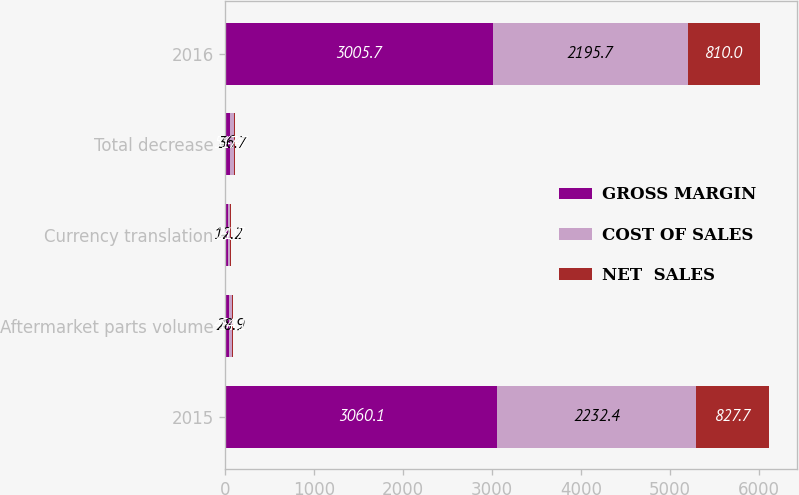<chart> <loc_0><loc_0><loc_500><loc_500><stacked_bar_chart><ecel><fcel>2015<fcel>Aftermarket parts volume<fcel>Currency translation<fcel>Total decrease<fcel>2016<nl><fcel>GROSS MARGIN<fcel>3060.1<fcel>43<fcel>33.9<fcel>54.4<fcel>3005.7<nl><fcel>COST OF SALES<fcel>2232.4<fcel>28.9<fcel>12.2<fcel>36.7<fcel>2195.7<nl><fcel>NET  SALES<fcel>827.7<fcel>14.1<fcel>21.7<fcel>17.7<fcel>810<nl></chart> 